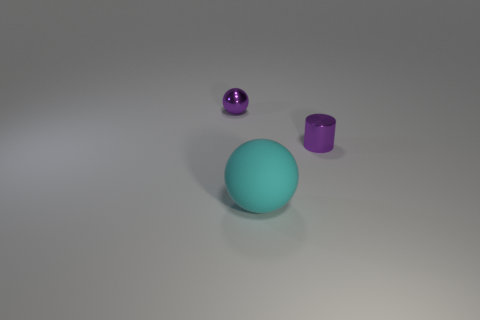Add 1 cylinders. How many objects exist? 4 Subtract all cylinders. How many objects are left? 2 Subtract 0 purple blocks. How many objects are left? 3 Subtract all big cyan spheres. Subtract all small purple spheres. How many objects are left? 1 Add 3 small spheres. How many small spheres are left? 4 Add 3 big purple rubber cubes. How many big purple rubber cubes exist? 3 